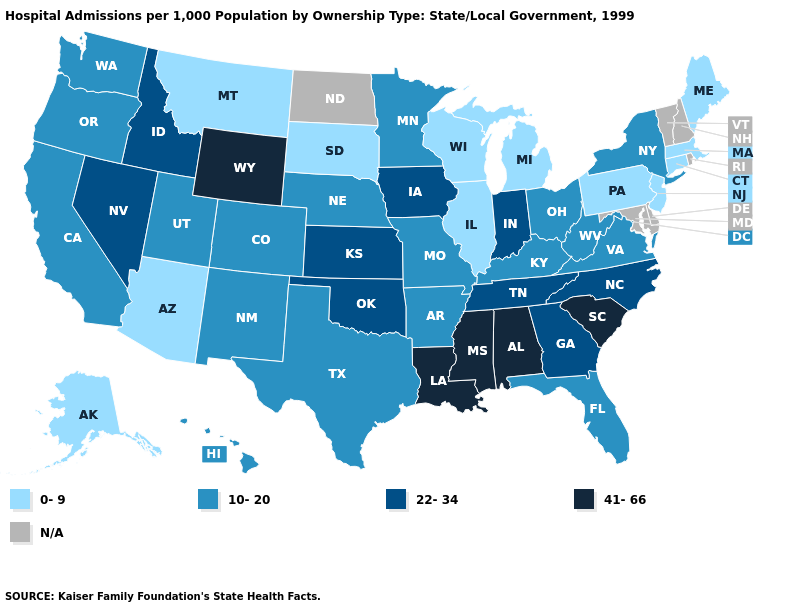What is the value of Missouri?
Write a very short answer. 10-20. Does Maine have the highest value in the Northeast?
Answer briefly. No. What is the lowest value in the USA?
Short answer required. 0-9. What is the value of Montana?
Write a very short answer. 0-9. What is the highest value in the USA?
Keep it brief. 41-66. Among the states that border Arkansas , which have the lowest value?
Give a very brief answer. Missouri, Texas. Among the states that border Illinois , which have the highest value?
Concise answer only. Indiana, Iowa. Name the states that have a value in the range 41-66?
Concise answer only. Alabama, Louisiana, Mississippi, South Carolina, Wyoming. Does Illinois have the lowest value in the USA?
Concise answer only. Yes. Name the states that have a value in the range N/A?
Concise answer only. Delaware, Maryland, New Hampshire, North Dakota, Rhode Island, Vermont. Among the states that border Montana , does South Dakota have the highest value?
Short answer required. No. How many symbols are there in the legend?
Answer briefly. 5. Which states have the lowest value in the West?
Answer briefly. Alaska, Arizona, Montana. What is the lowest value in the MidWest?
Quick response, please. 0-9. Does Louisiana have the highest value in the USA?
Concise answer only. Yes. 